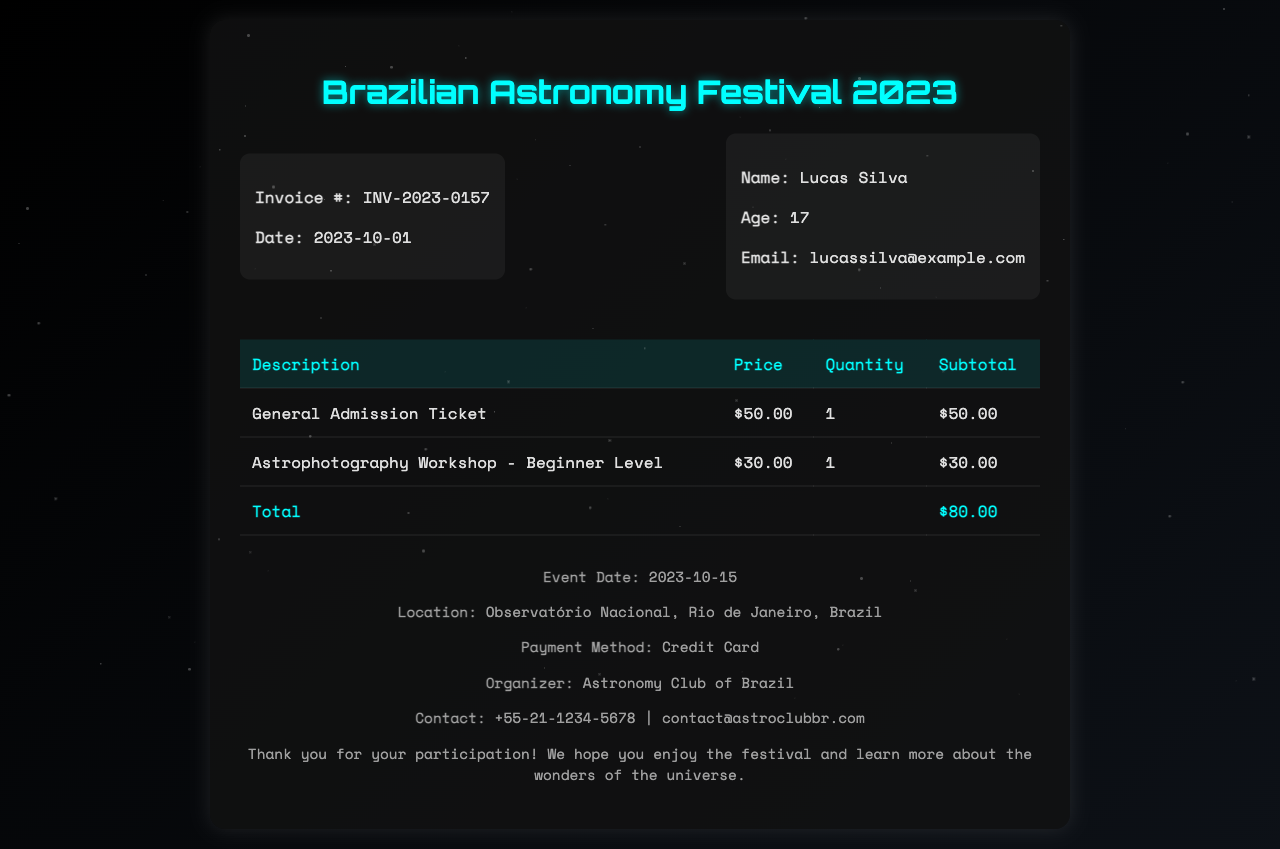what is the invoice number? The invoice number can be found in the invoice details section, which notes INV-2023-0157.
Answer: INV-2023-0157 who is the attendee? The attendee's name is mentioned in the attendee details section, which states Lucas Silva.
Answer: Lucas Silva how much does the general admission ticket cost? The general admission ticket price is listed in the table under the Price column, which shows $50.00.
Answer: $50.00 what is the total amount due? The total amount due is calculated in the table and noted at the bottom, which reflects $80.00.
Answer: $80.00 which workshop is included in the invoice? The included workshop is specified in the table as "Astrophotography Workshop - Beginner Level."
Answer: Astrophotography Workshop - Beginner Level what payment method was used? The payment method is stated in the footer section, where it mentions Credit Card.
Answer: Credit Card when is the event date? The event date is specified in the footer section, which indicates 2023-10-15.
Answer: 2023-10-15 where is the event location? The event location is provided in the footer, mentioning Observatório Nacional, Rio de Janeiro, Brazil.
Answer: Observatório Nacional, Rio de Janeiro, Brazil 